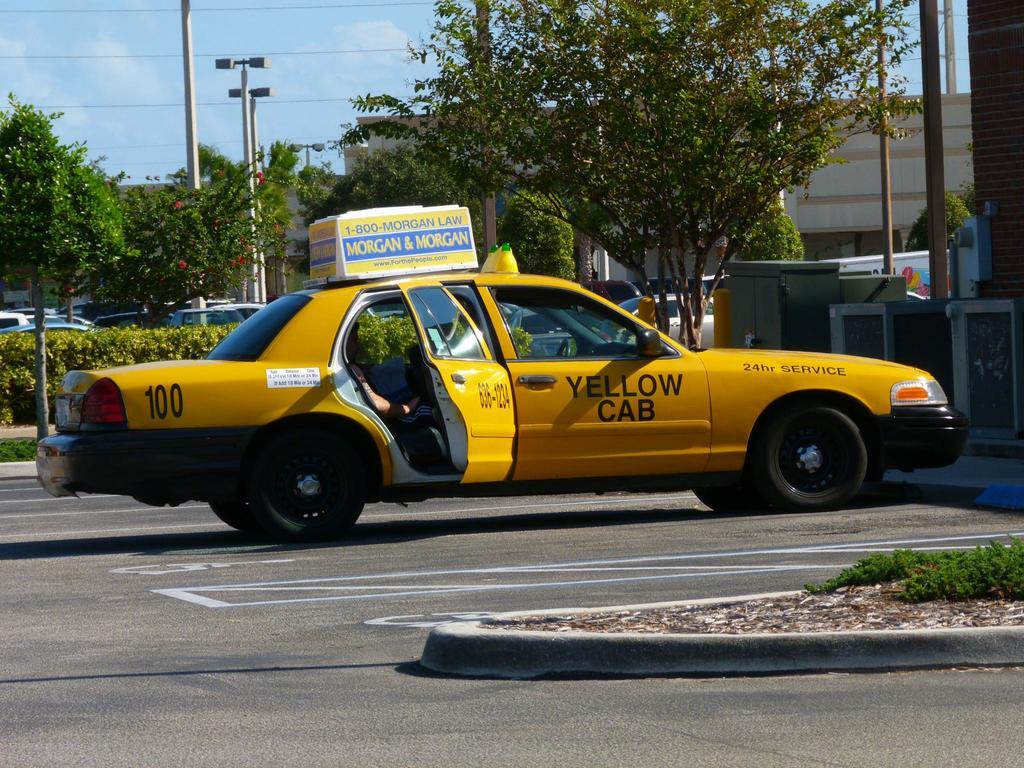Provide a one-sentence caption for the provided image. A parked yellow taxi cab which has the number 100 on it. 